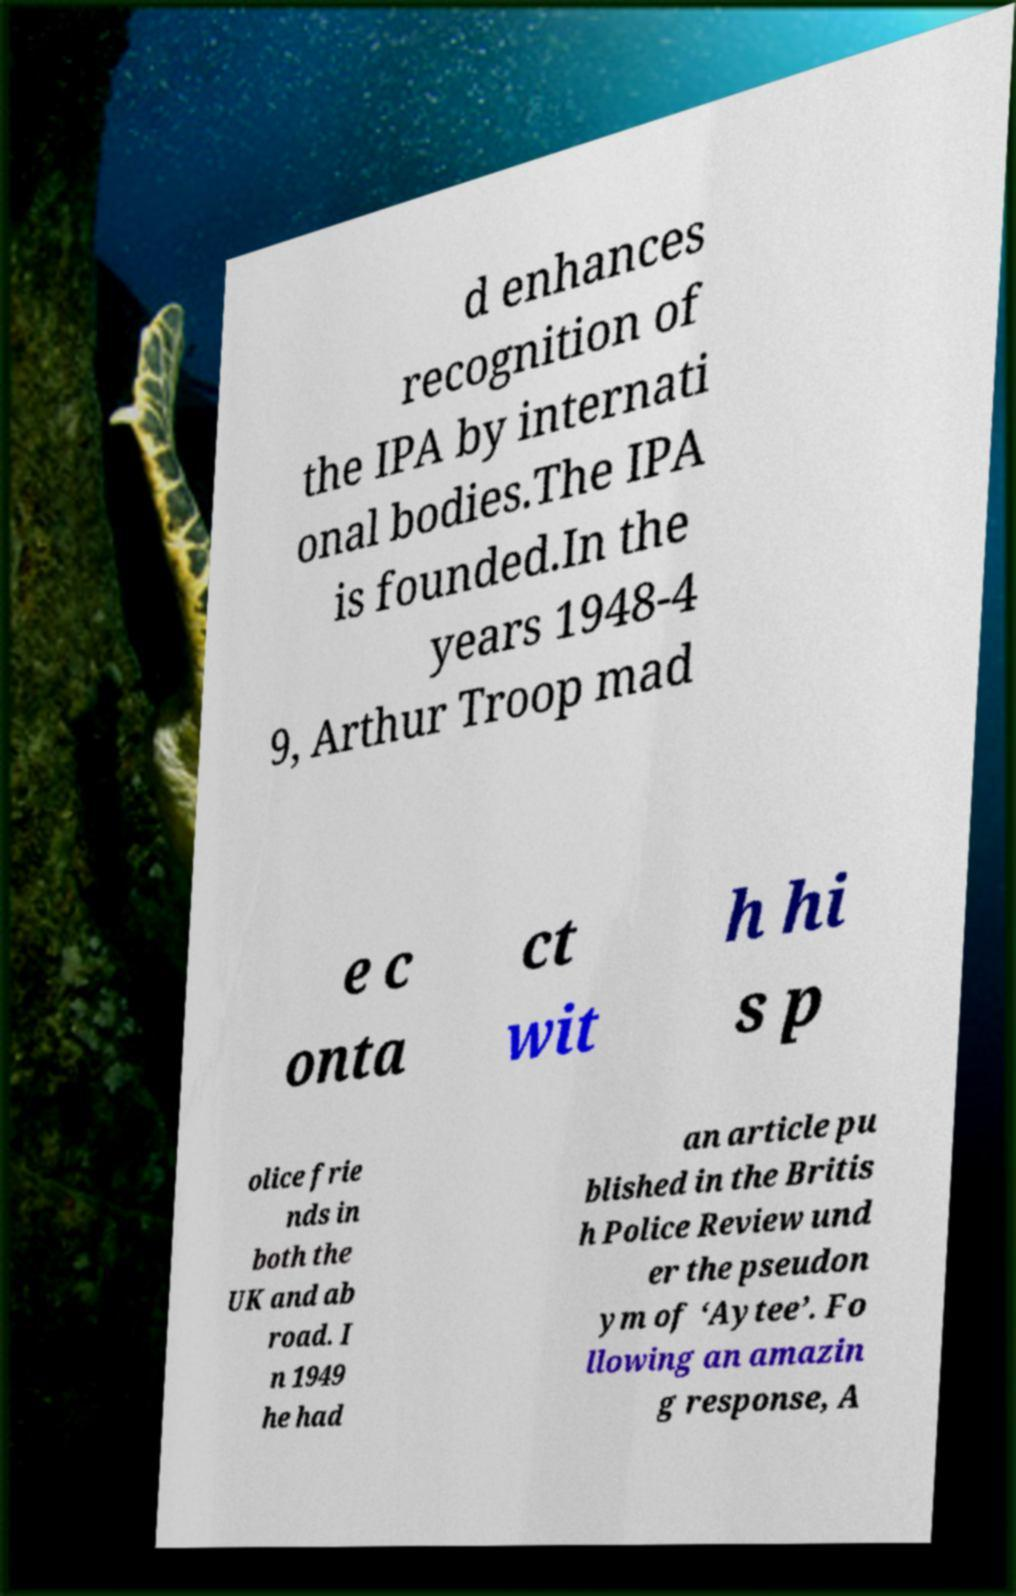I need the written content from this picture converted into text. Can you do that? d enhances recognition of the IPA by internati onal bodies.The IPA is founded.In the years 1948-4 9, Arthur Troop mad e c onta ct wit h hi s p olice frie nds in both the UK and ab road. I n 1949 he had an article pu blished in the Britis h Police Review und er the pseudon ym of ‘Aytee’. Fo llowing an amazin g response, A 